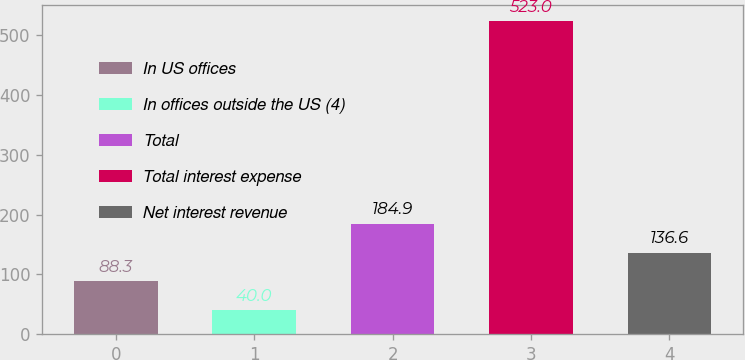<chart> <loc_0><loc_0><loc_500><loc_500><bar_chart><fcel>In US offices<fcel>In offices outside the US (4)<fcel>Total<fcel>Total interest expense<fcel>Net interest revenue<nl><fcel>88.3<fcel>40<fcel>184.9<fcel>523<fcel>136.6<nl></chart> 